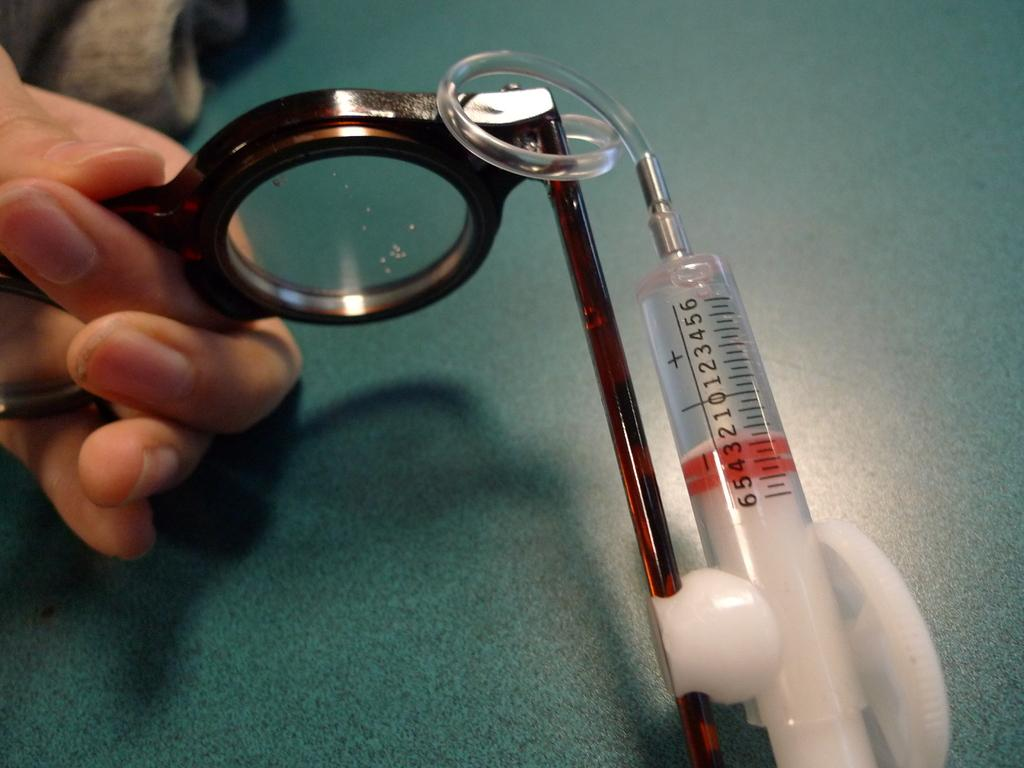Provide a one-sentence caption for the provided image. A person is holding a syringe that is numbered from 0 to 6. 